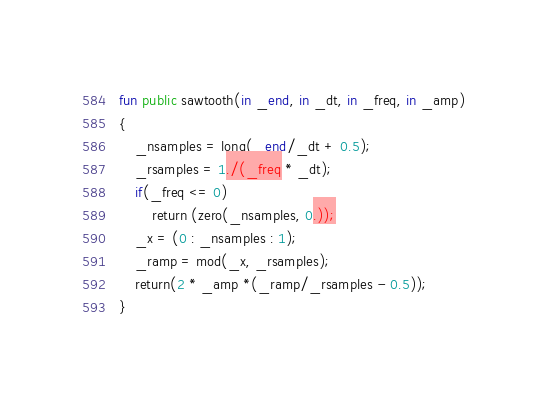<code> <loc_0><loc_0><loc_500><loc_500><_SML_>fun public sawtooth(in _end, in _dt, in _freq, in _amp)
{
    _nsamples = long(_end/_dt + 0.5);
    _rsamples = 1./(_freq * _dt);
    if(_freq <= 0)
        return (zero(_nsamples, 0.));
    _x = (0 : _nsamples : 1);
    _ramp = mod(_x, _rsamples);
    return(2 * _amp *(_ramp/_rsamples - 0.5));
}
</code> 